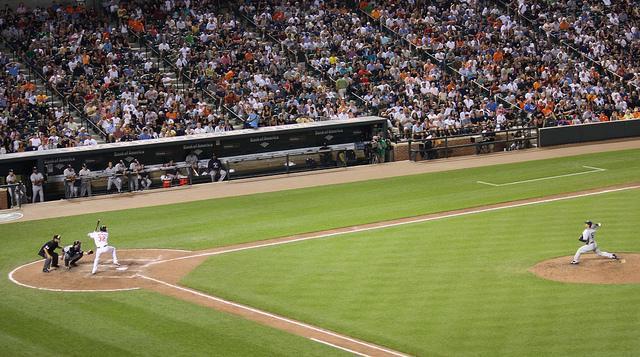How many of the stuffed bears have a heart on its chest?
Give a very brief answer. 0. 